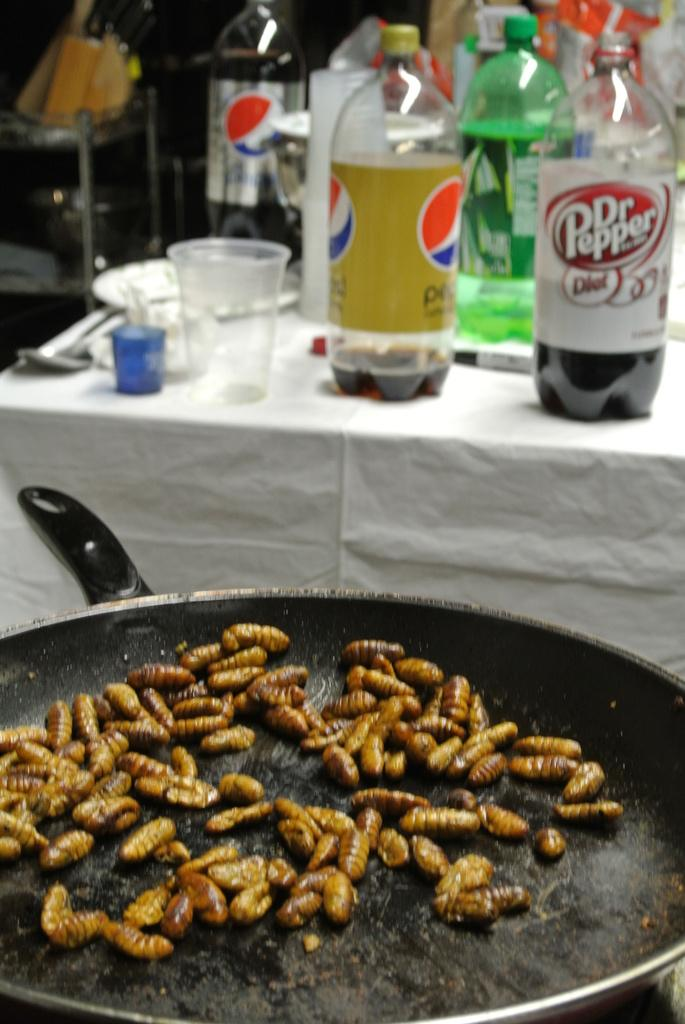<image>
Create a compact narrative representing the image presented. A skillet of grubs are being cooked in front of a table with a Dr. Pepper and other sodas on it. 